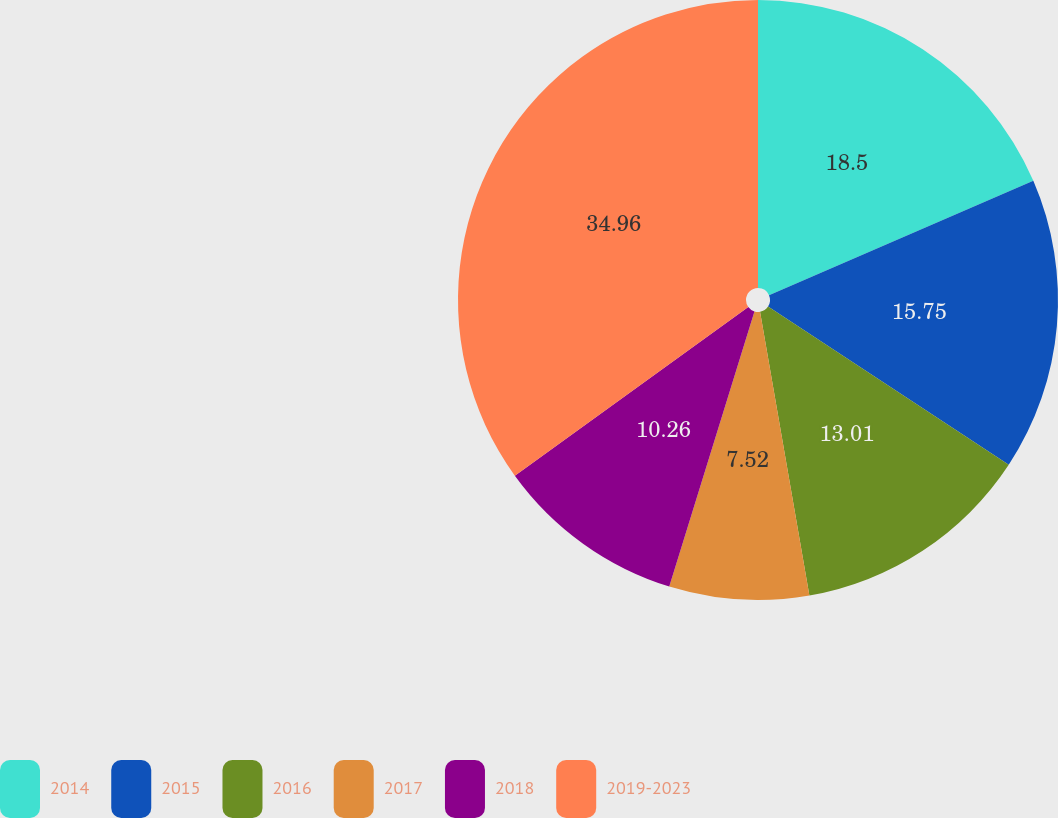<chart> <loc_0><loc_0><loc_500><loc_500><pie_chart><fcel>2014<fcel>2015<fcel>2016<fcel>2017<fcel>2018<fcel>2019-2023<nl><fcel>18.5%<fcel>15.75%<fcel>13.01%<fcel>7.52%<fcel>10.26%<fcel>34.96%<nl></chart> 